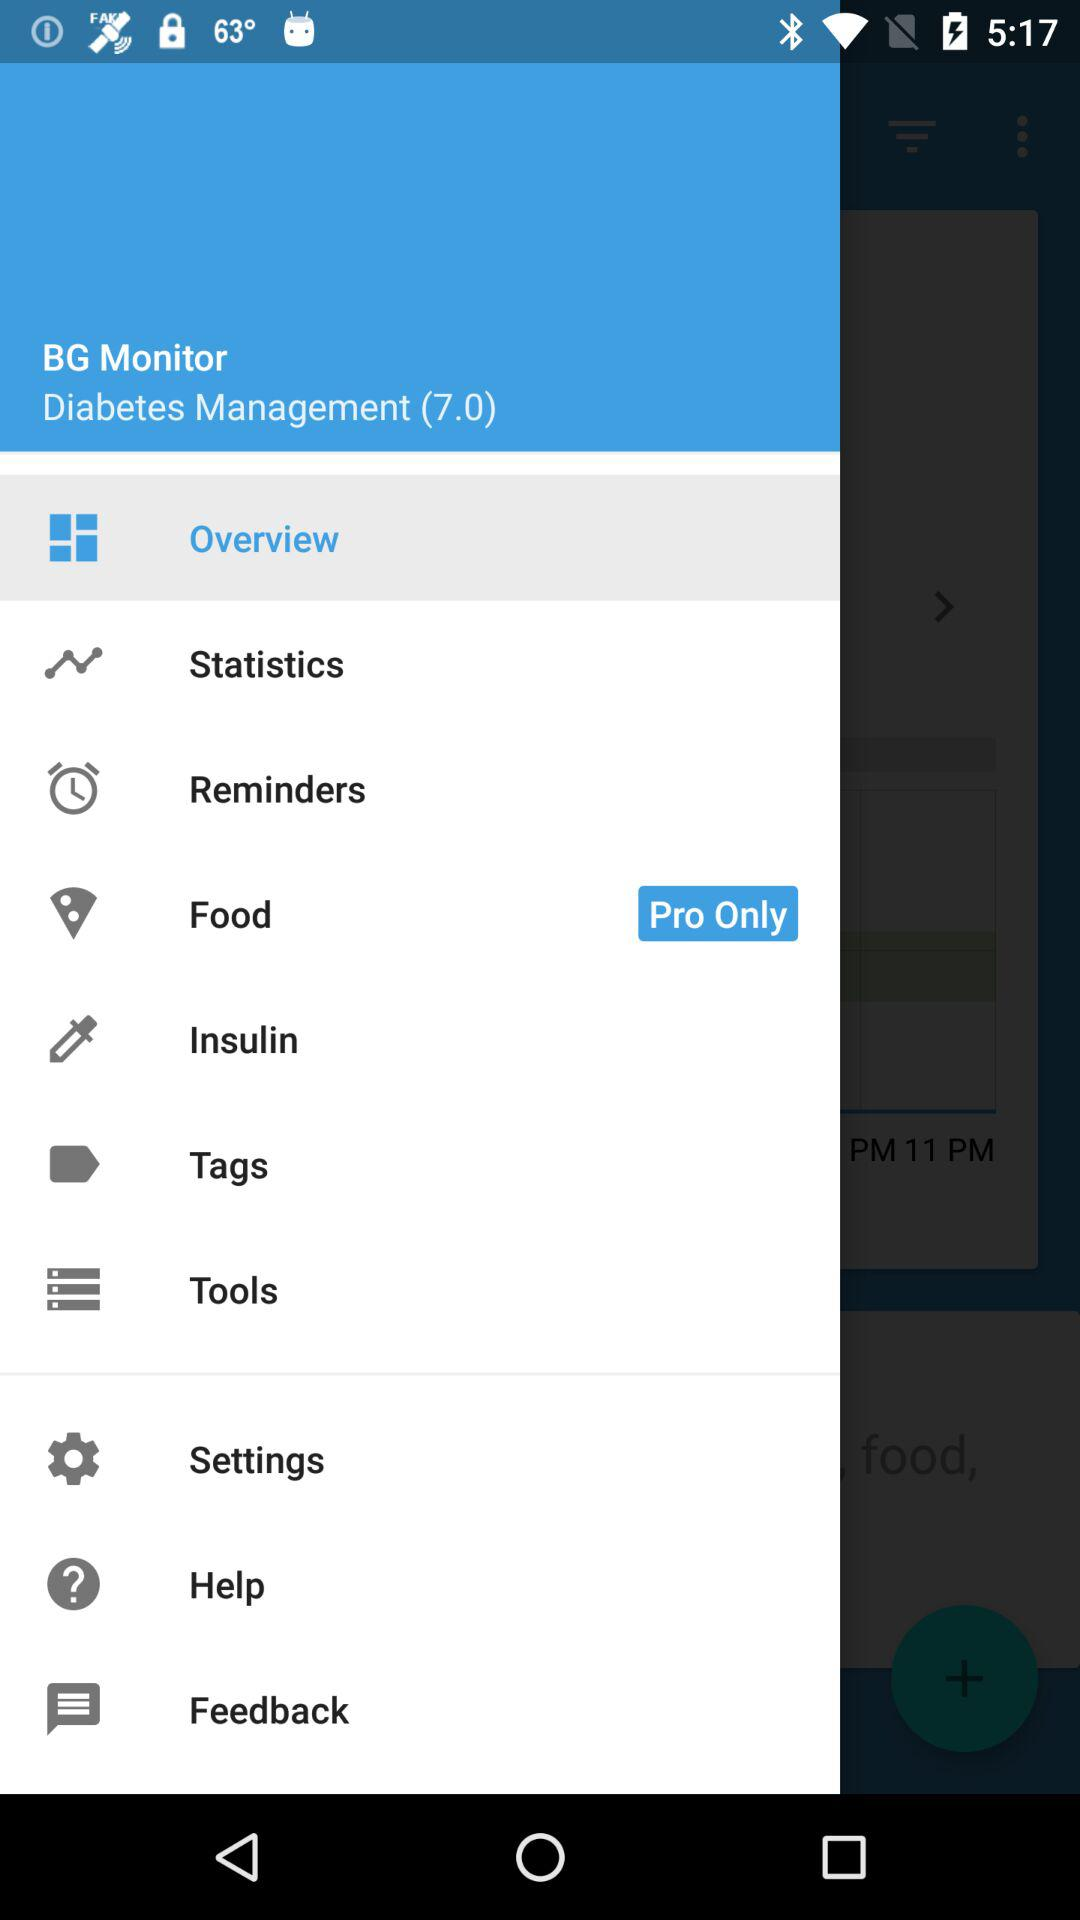Which option is selected? The selected option is "Overview". 